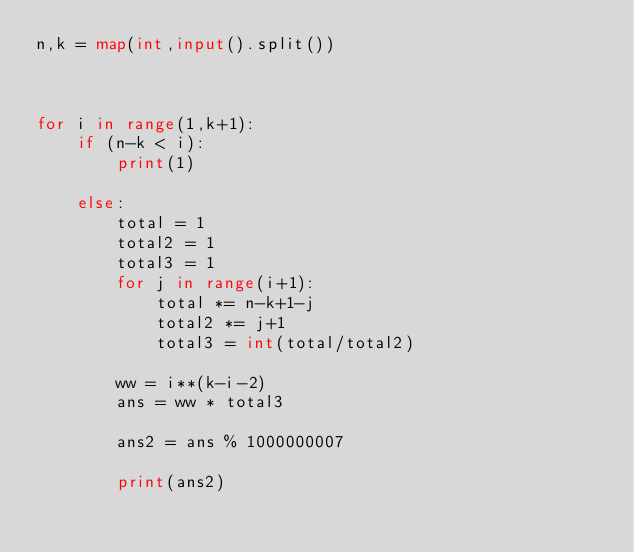<code> <loc_0><loc_0><loc_500><loc_500><_Python_>n,k = map(int,input().split())



for i in range(1,k+1):
    if (n-k < i):
        print(1)

    else:
        total = 1
        total2 = 1
        total3 = 1
        for j in range(i+1):
            total *= n-k+1-j
            total2 *= j+1
            total3 = int(total/total2)
            
        ww = i**(k-i-2)
        ans = ww * total3

        ans2 = ans % 1000000007

        print(ans2)
    
</code> 